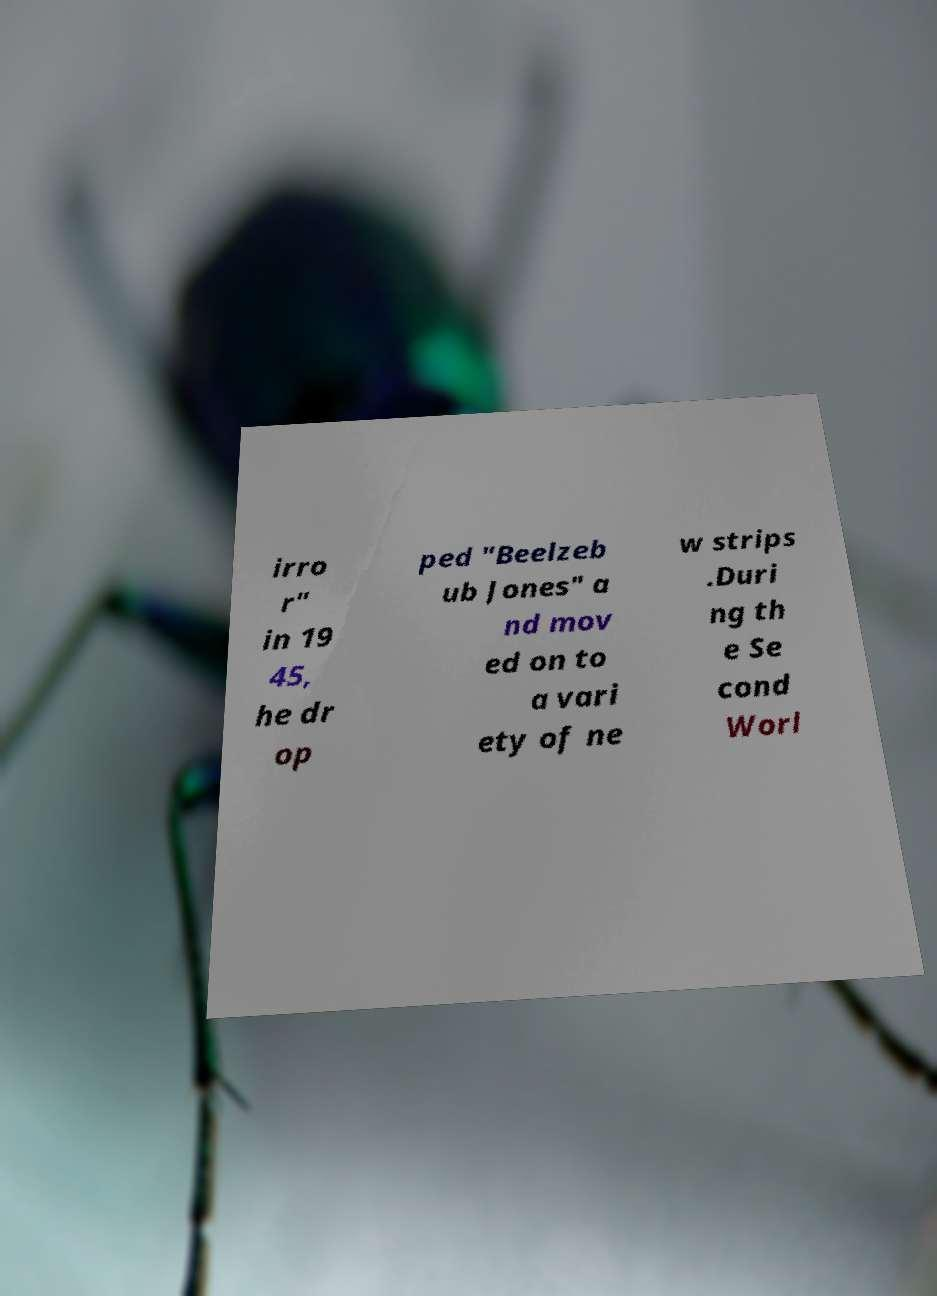There's text embedded in this image that I need extracted. Can you transcribe it verbatim? irro r" in 19 45, he dr op ped "Beelzeb ub Jones" a nd mov ed on to a vari ety of ne w strips .Duri ng th e Se cond Worl 